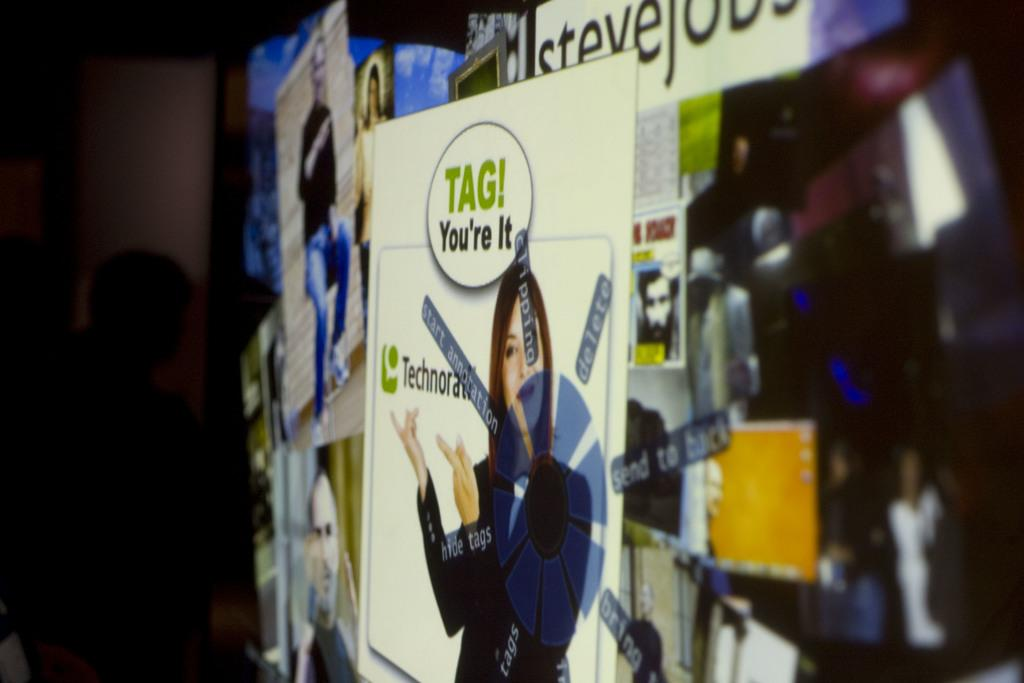Provide a one-sentence caption for the provided image. An advertisement to Technocrati with the line Tag You're It hangs on a wall. 